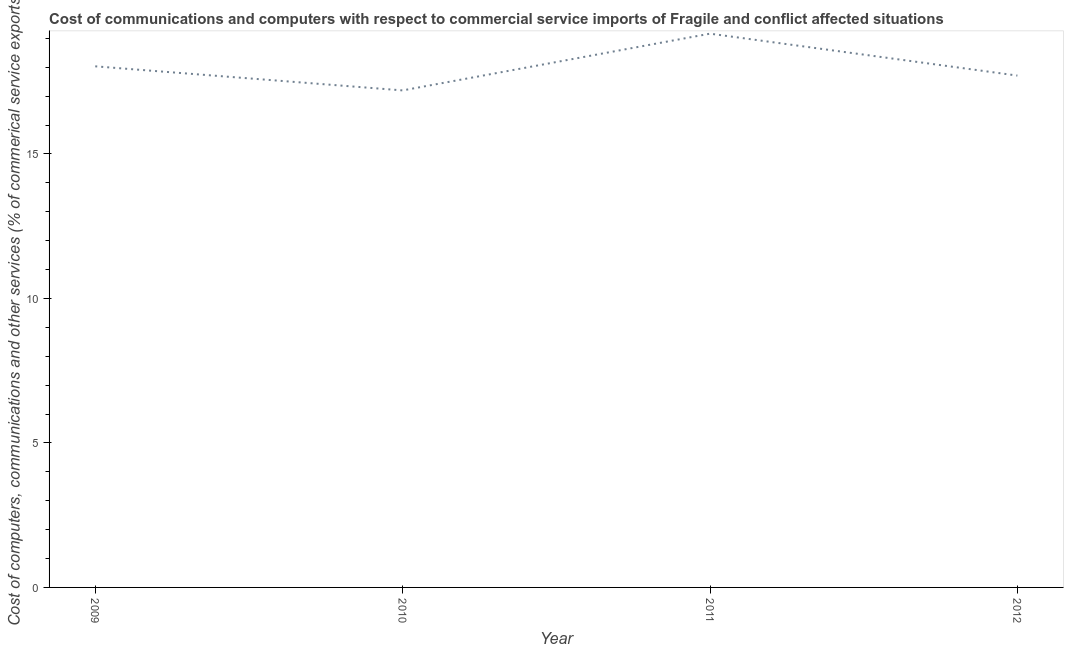What is the cost of communications in 2012?
Offer a very short reply. 17.71. Across all years, what is the maximum cost of communications?
Offer a terse response. 19.16. Across all years, what is the minimum cost of communications?
Ensure brevity in your answer.  17.2. In which year was the  computer and other services minimum?
Keep it short and to the point. 2010. What is the sum of the cost of communications?
Give a very brief answer. 72.1. What is the difference between the  computer and other services in 2009 and 2011?
Keep it short and to the point. -1.13. What is the average  computer and other services per year?
Make the answer very short. 18.03. What is the median  computer and other services?
Offer a very short reply. 17.87. In how many years, is the  computer and other services greater than 4 %?
Your response must be concise. 4. Do a majority of the years between 2009 and 2012 (inclusive) have  computer and other services greater than 13 %?
Give a very brief answer. Yes. What is the ratio of the  computer and other services in 2009 to that in 2011?
Keep it short and to the point. 0.94. Is the  computer and other services in 2011 less than that in 2012?
Offer a very short reply. No. Is the difference between the  computer and other services in 2009 and 2010 greater than the difference between any two years?
Give a very brief answer. No. What is the difference between the highest and the second highest  computer and other services?
Give a very brief answer. 1.13. What is the difference between the highest and the lowest  computer and other services?
Your response must be concise. 1.96. In how many years, is the cost of communications greater than the average cost of communications taken over all years?
Provide a short and direct response. 2. Does the  computer and other services monotonically increase over the years?
Your answer should be compact. No. How many lines are there?
Keep it short and to the point. 1. What is the title of the graph?
Your answer should be compact. Cost of communications and computers with respect to commercial service imports of Fragile and conflict affected situations. What is the label or title of the X-axis?
Offer a very short reply. Year. What is the label or title of the Y-axis?
Offer a terse response. Cost of computers, communications and other services (% of commerical service exports). What is the Cost of computers, communications and other services (% of commerical service exports) of 2009?
Give a very brief answer. 18.03. What is the Cost of computers, communications and other services (% of commerical service exports) in 2010?
Ensure brevity in your answer.  17.2. What is the Cost of computers, communications and other services (% of commerical service exports) in 2011?
Give a very brief answer. 19.16. What is the Cost of computers, communications and other services (% of commerical service exports) in 2012?
Keep it short and to the point. 17.71. What is the difference between the Cost of computers, communications and other services (% of commerical service exports) in 2009 and 2010?
Your response must be concise. 0.83. What is the difference between the Cost of computers, communications and other services (% of commerical service exports) in 2009 and 2011?
Ensure brevity in your answer.  -1.13. What is the difference between the Cost of computers, communications and other services (% of commerical service exports) in 2009 and 2012?
Give a very brief answer. 0.32. What is the difference between the Cost of computers, communications and other services (% of commerical service exports) in 2010 and 2011?
Provide a succinct answer. -1.96. What is the difference between the Cost of computers, communications and other services (% of commerical service exports) in 2010 and 2012?
Your answer should be compact. -0.51. What is the difference between the Cost of computers, communications and other services (% of commerical service exports) in 2011 and 2012?
Keep it short and to the point. 1.45. What is the ratio of the Cost of computers, communications and other services (% of commerical service exports) in 2009 to that in 2010?
Ensure brevity in your answer.  1.05. What is the ratio of the Cost of computers, communications and other services (% of commerical service exports) in 2009 to that in 2011?
Ensure brevity in your answer.  0.94. What is the ratio of the Cost of computers, communications and other services (% of commerical service exports) in 2010 to that in 2011?
Ensure brevity in your answer.  0.9. What is the ratio of the Cost of computers, communications and other services (% of commerical service exports) in 2011 to that in 2012?
Keep it short and to the point. 1.08. 